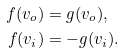Convert formula to latex. <formula><loc_0><loc_0><loc_500><loc_500>f ( v _ { o } ) & = g ( v _ { o } ) , \\ f ( v _ { i } ) & = - g ( v _ { i } ) .</formula> 